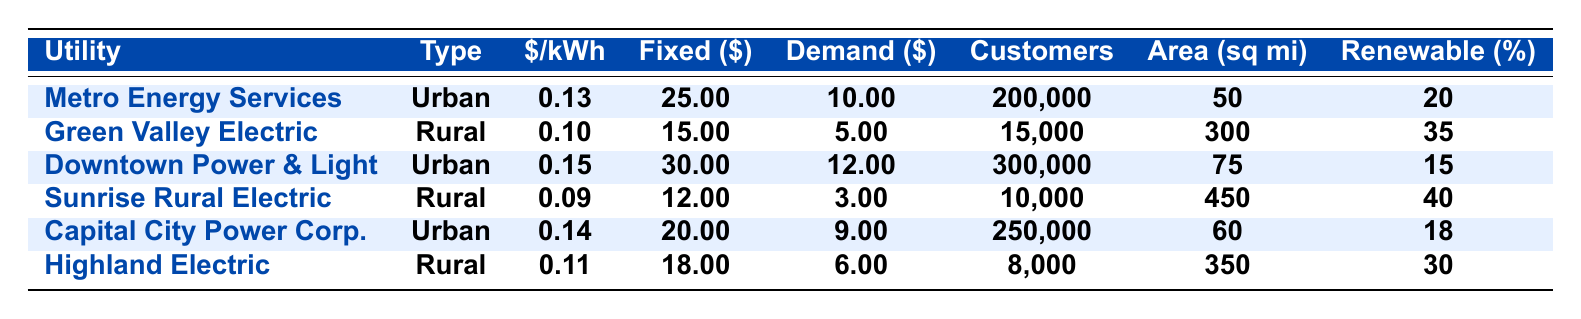What is the average rate per kWh for urban utilities? To find the average, we sum the rates for the urban utilities (0.13 + 0.15 + 0.14 = 0.42) and divide by the number of urban utilities (3). Thus, the average is 0.42 / 3 = 0.14.
Answer: 0.14 What is the fixed monthly charge for Sunrise Rural Electric Cooperative? The fixed monthly charge for Sunrise Rural Electric Cooperative is listed in the table as $12.00.
Answer: 12.00 What is the customer base for Highland Electric Cooperative? The customer base for Highland Electric Cooperative is provided in the table as 8,000 customers.
Answer: 8000 Is the average rate per kWh for rural electric cooperatives generally less than that of urban utilities? By comparing average rates, rural cooperatives have rates of 0.10, 0.09, and 0.11, which are less than urban rates of 0.13, 0.15, and 0.14. Thus, the statement is true.
Answer: Yes What is the total combined fixed monthly charge for all listed urban utilities? The total fixed monthly charge is calculated by summing the charges for urban utilities: 25.00 + 30.00 + 20.00 = 75.00.
Answer: 75.00 How much larger is the service area size for Sunrise Rural Electric Cooperative compared to Metro Energy Services? The service area size for Sunrise is 450 sq mi and Metro is 50 sq mi. The difference is 450 - 50 = 400 sq mi.
Answer: 400 sq mi What percentage of renewable energy is offered by the utility with the highest average rate? Downtown Power & Light has the highest average rate of 0.15, and it offers 15% renewable energy according to the table.
Answer: 15% Which has a lower demand charge: Green Valley Electric Cooperative or Downtown Power & Light? The demand charges are $5.00 for Green Valley and $12.00 for Downtown Power & Light. Since $5.00 is less than $12.00, Green Valley has the lower charge.
Answer: Green Valley Electric Cooperative What is the average customer base size of rural electric cooperatives listed in the table? The customer bases are 15,000, 10,000, and 8,000. Adding them gives 33,000, and dividing by 3 yields an average of 11,000.
Answer: 11,000 Does the Urban Utility category have a larger average customer base than the Rural Electric Cooperative category? The urban utilities' customer bases are 200,000, 300,000, and 250,000, averaging 250,000. The rural cooperatives average 11,000 customers. Therefore, true.
Answer: Yes 